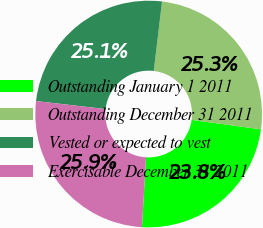Convert chart to OTSL. <chart><loc_0><loc_0><loc_500><loc_500><pie_chart><fcel>Outstanding January 1 2011<fcel>Outstanding December 31 2011<fcel>Vested or expected to vest<fcel>Exercisable December 31 2011<nl><fcel>23.79%<fcel>25.27%<fcel>25.06%<fcel>25.88%<nl></chart> 